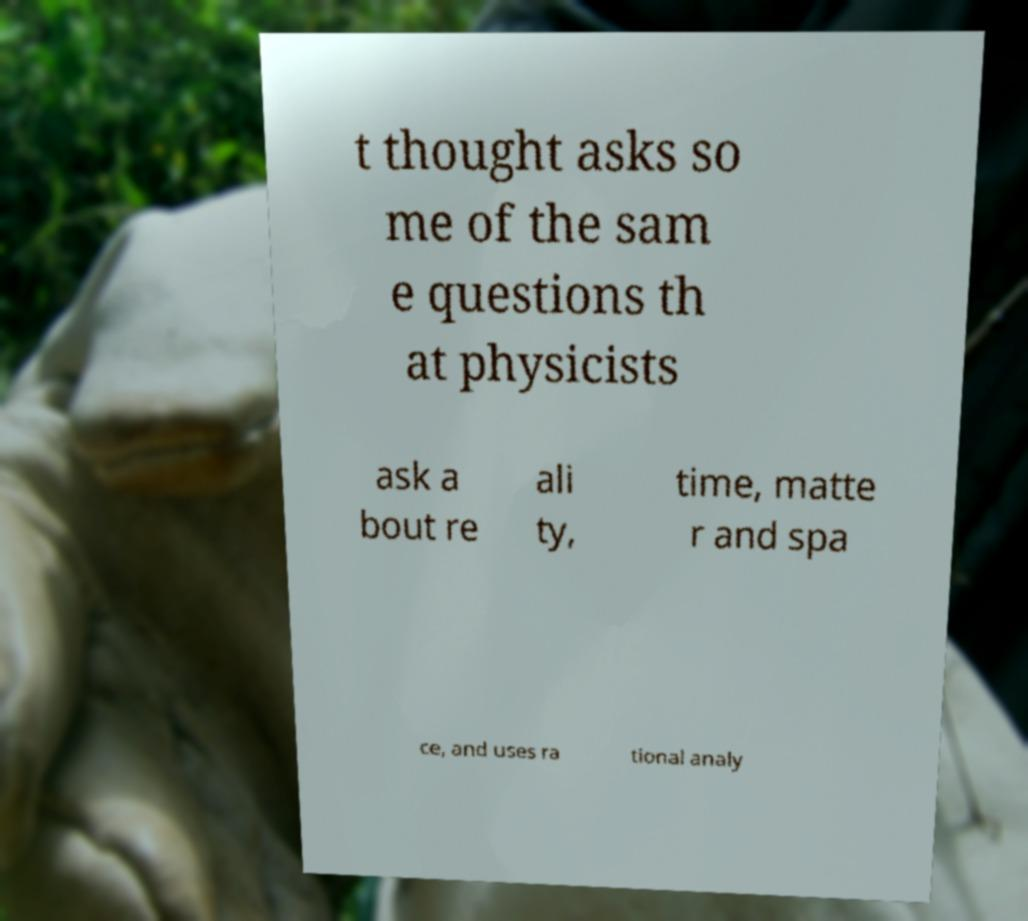Please read and relay the text visible in this image. What does it say? t thought asks so me of the sam e questions th at physicists ask a bout re ali ty, time, matte r and spa ce, and uses ra tional analy 